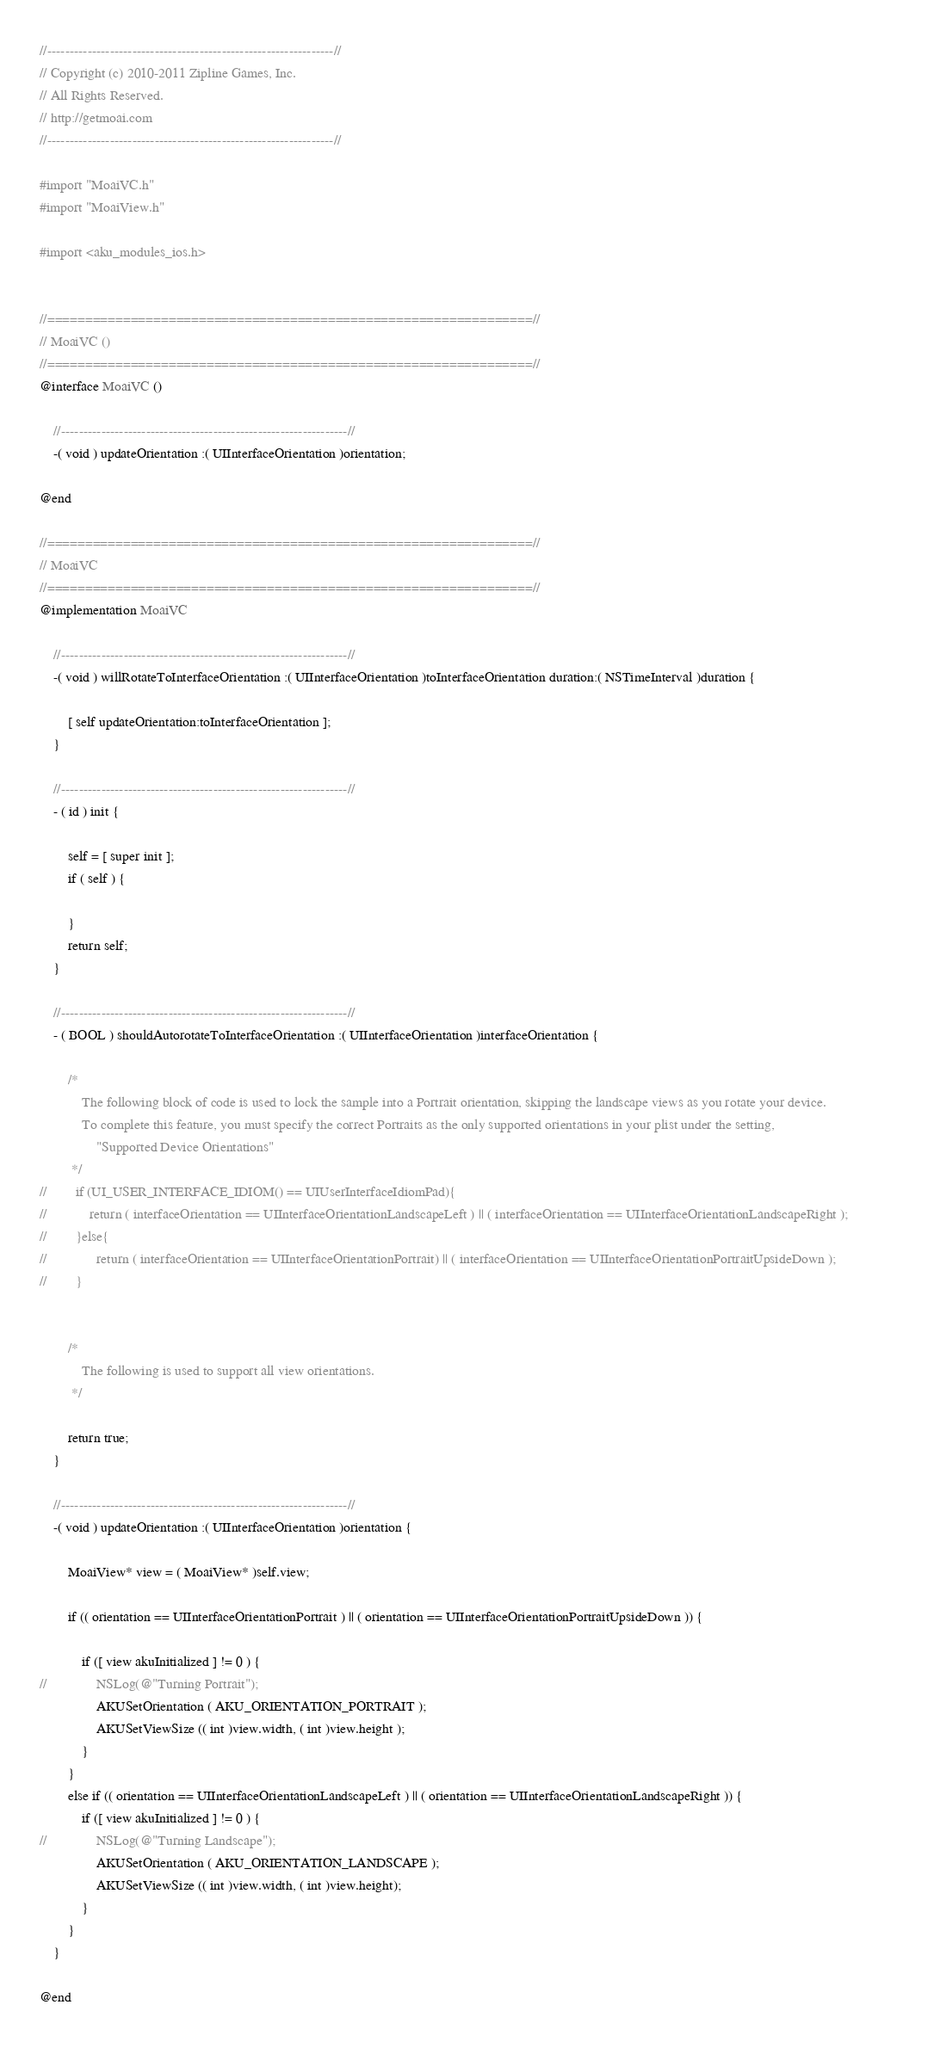Convert code to text. <code><loc_0><loc_0><loc_500><loc_500><_ObjectiveC_>//----------------------------------------------------------------//
// Copyright (c) 2010-2011 Zipline Games, Inc. 
// All Rights Reserved. 
// http://getmoai.com
//----------------------------------------------------------------//

#import "MoaiVC.h"
#import "MoaiView.h"

#import <aku_modules_ios.h>


//================================================================//
// MoaiVC ()
//================================================================//
@interface MoaiVC ()

	//----------------------------------------------------------------//	
	-( void ) updateOrientation :( UIInterfaceOrientation )orientation;

@end

//================================================================//
// MoaiVC
//================================================================//
@implementation MoaiVC

	//----------------------------------------------------------------//
	-( void ) willRotateToInterfaceOrientation :( UIInterfaceOrientation )toInterfaceOrientation duration:( NSTimeInterval )duration {
		
		[ self updateOrientation:toInterfaceOrientation ];
	}

	//----------------------------------------------------------------//
	- ( id ) init {
	
		self = [ super init ];
		if ( self ) {
		
		}
		return self;
	}

	//----------------------------------------------------------------//
	- ( BOOL ) shouldAutorotateToInterfaceOrientation :( UIInterfaceOrientation )interfaceOrientation {
		
        /*
            The following block of code is used to lock the sample into a Portrait orientation, skipping the landscape views as you rotate your device.
            To complete this feature, you must specify the correct Portraits as the only supported orientations in your plist under the setting,
                "Supported Device Orientations"
         */
//        if (UI_USER_INTERFACE_IDIOM() == UIUserInterfaceIdiomPad){
//            return ( interfaceOrientation == UIInterfaceOrientationLandscapeLeft ) || ( interfaceOrientation == UIInterfaceOrientationLandscapeRight );  	          
//    	  }else{
//              return ( interfaceOrientation == UIInterfaceOrientationPortrait) || ( interfaceOrientation == UIInterfaceOrientationPortraitUpsideDown );
//    	  }

        
        /*
            The following is used to support all view orientations.
         */
        
        return true;
	}
	
	//----------------------------------------------------------------//
	-( void ) updateOrientation :( UIInterfaceOrientation )orientation {
		
		MoaiView* view = ( MoaiView* )self.view;        
		
		if (( orientation == UIInterfaceOrientationPortrait ) || ( orientation == UIInterfaceOrientationPortraitUpsideDown )) {
            
            if ([ view akuInitialized ] != 0 ) {
//				NSLog(@"Turning Portrait");
                AKUSetOrientation ( AKU_ORIENTATION_PORTRAIT );
                AKUSetViewSize (( int )view.width, ( int )view.height );
            }
		}
		else if (( orientation == UIInterfaceOrientationLandscapeLeft ) || ( orientation == UIInterfaceOrientationLandscapeRight )) {
            if ([ view akuInitialized ] != 0 ) {
//				NSLog(@"Turning Landscape");
                AKUSetOrientation ( AKU_ORIENTATION_LANDSCAPE );
                AKUSetViewSize (( int )view.width, ( int )view.height);
            }
		}
	}
	
@end</code> 